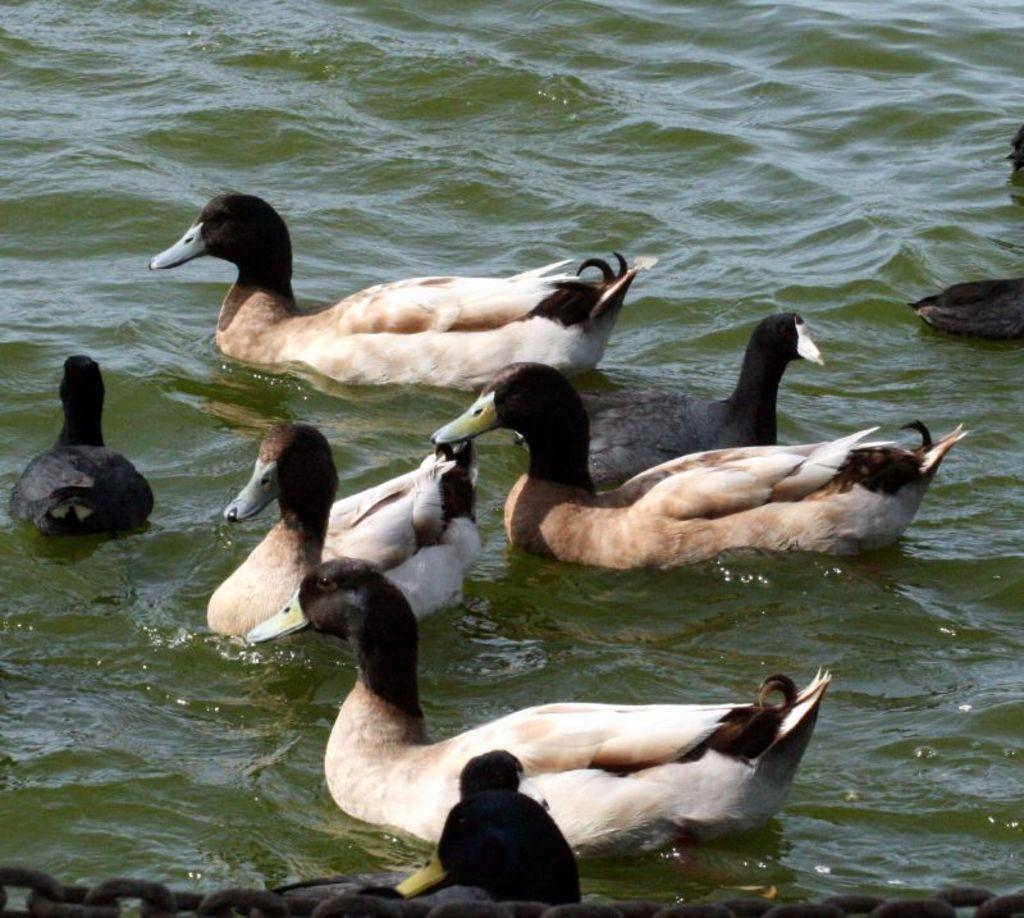What animals are in the center of the image? There are ducks in the center of the image. Where are the ducks located? The ducks are in the water. What type of art can be seen hanging on the wall in the image? There is no wall or art present in the image; it features ducks in the water. 